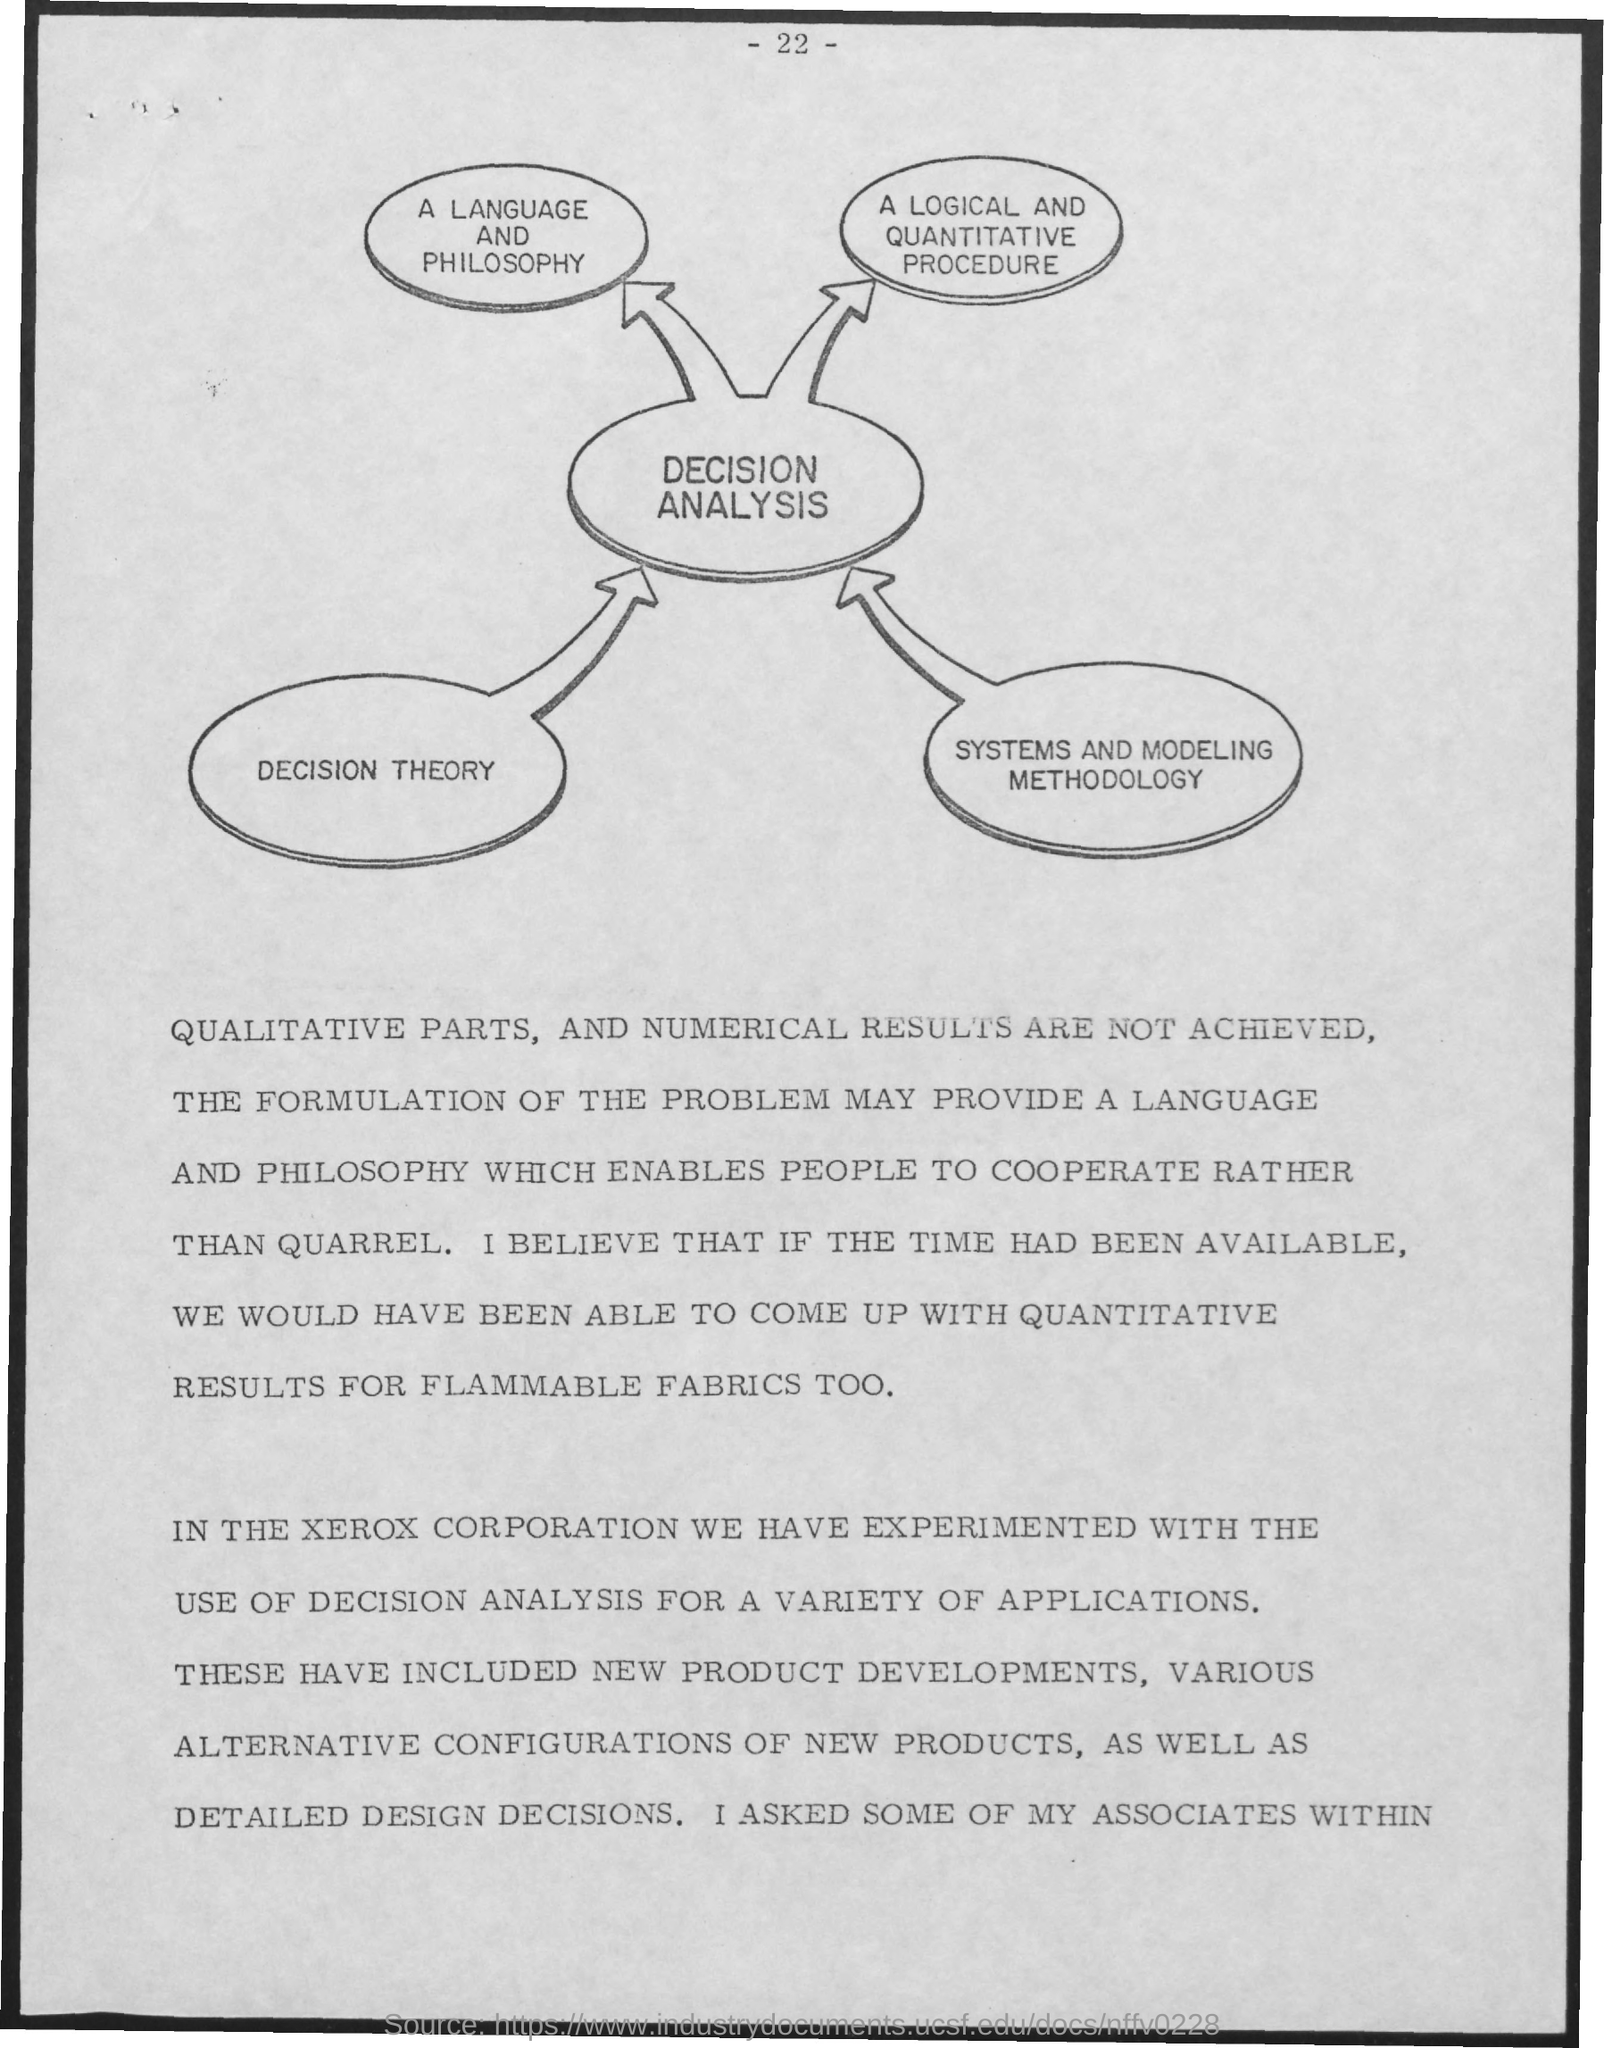Give some essential details in this illustration. The page number is -22-.. 